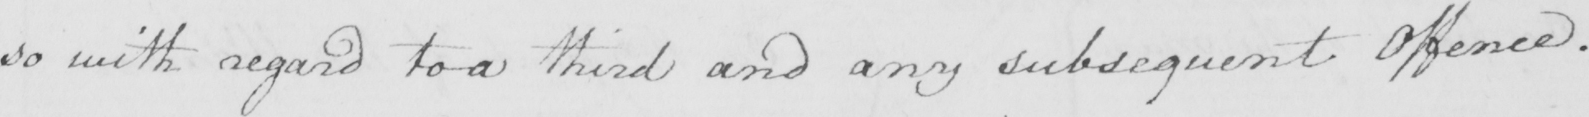Transcribe the text shown in this historical manuscript line. so with regard to a third and any subsequent Offence . 